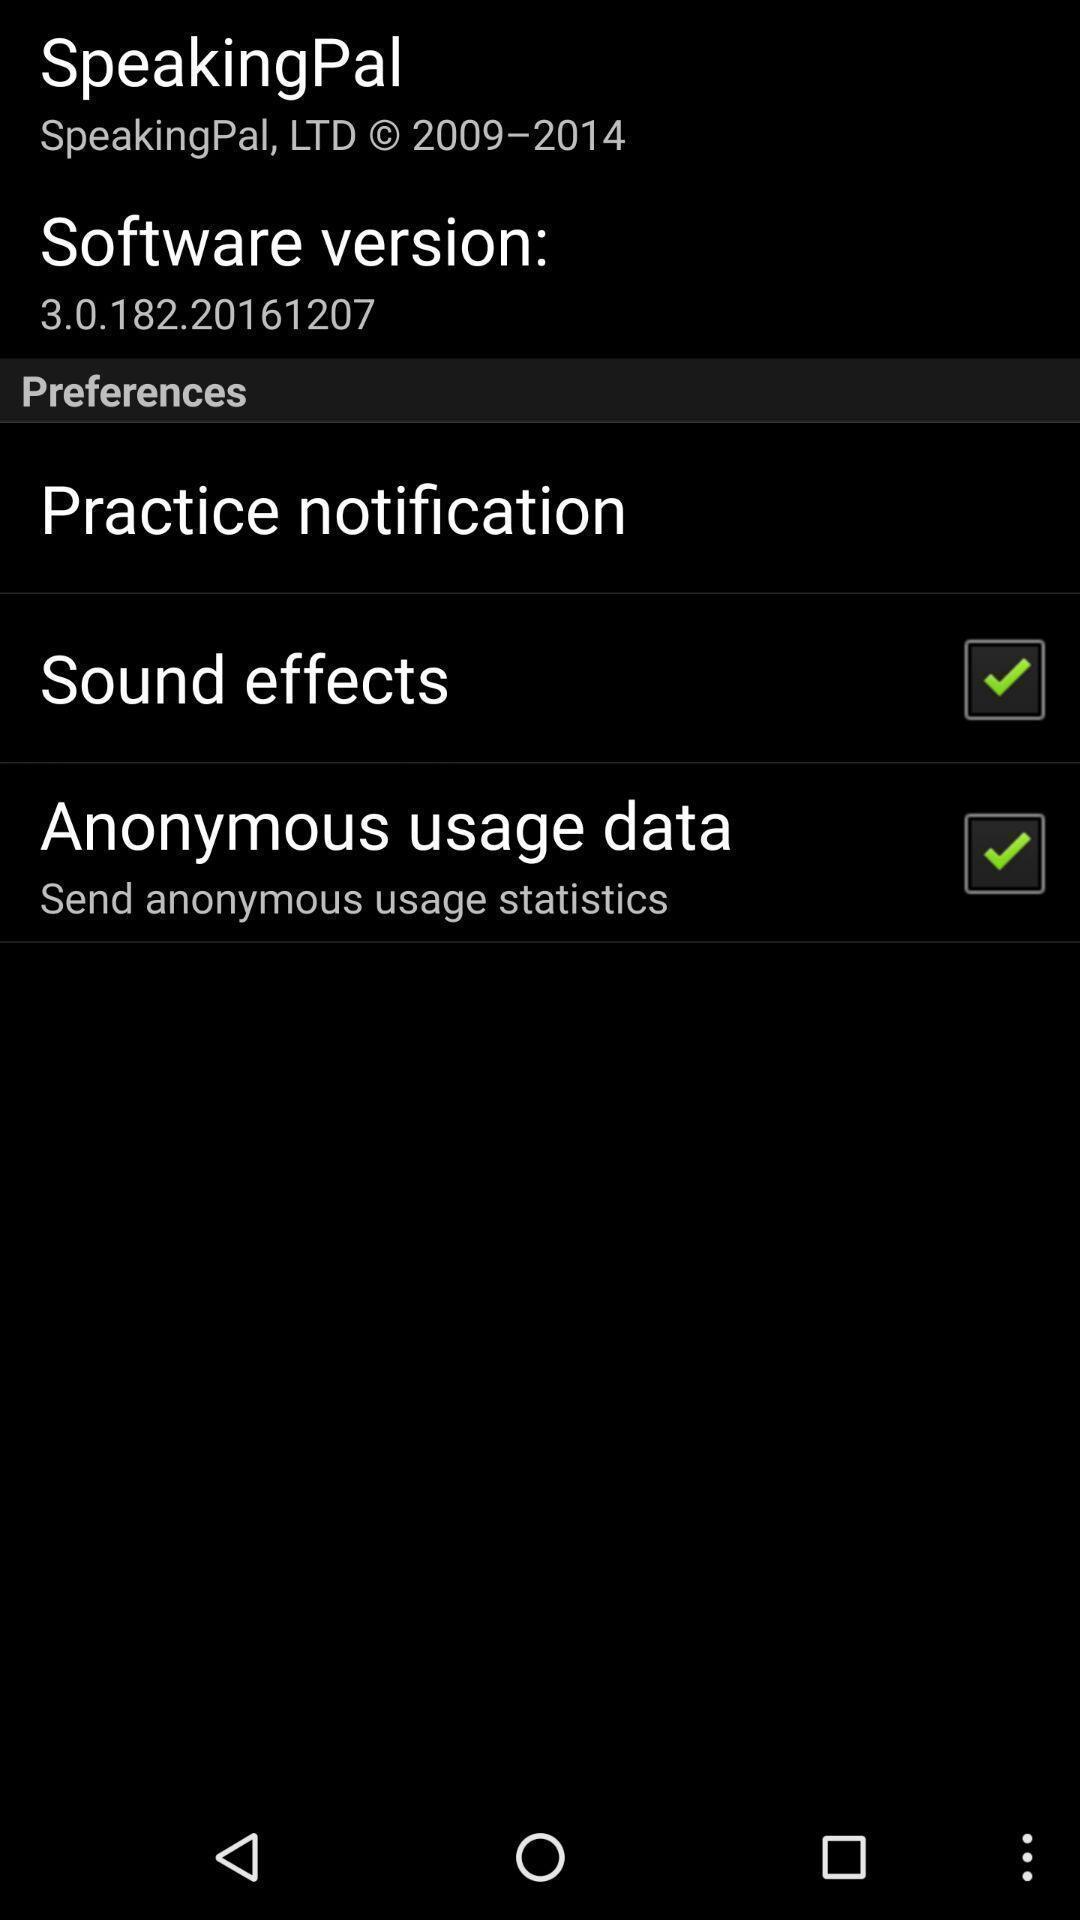What details can you identify in this image? Screen displaying about preferences in a fun learning app. 